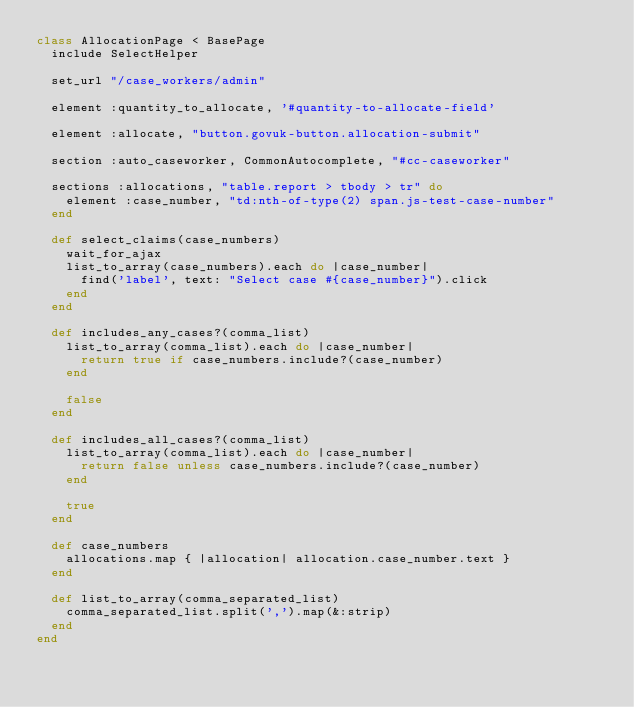<code> <loc_0><loc_0><loc_500><loc_500><_Ruby_>class AllocationPage < BasePage
  include SelectHelper

  set_url "/case_workers/admin"

  element :quantity_to_allocate, '#quantity-to-allocate-field'

  element :allocate, "button.govuk-button.allocation-submit"

  section :auto_caseworker, CommonAutocomplete, "#cc-caseworker"

  sections :allocations, "table.report > tbody > tr" do
    element :case_number, "td:nth-of-type(2) span.js-test-case-number"
  end

  def select_claims(case_numbers)
    wait_for_ajax
    list_to_array(case_numbers).each do |case_number|
      find('label', text: "Select case #{case_number}").click
    end
  end

  def includes_any_cases?(comma_list)
    list_to_array(comma_list).each do |case_number|
      return true if case_numbers.include?(case_number)
    end

    false
  end

  def includes_all_cases?(comma_list)
    list_to_array(comma_list).each do |case_number|
      return false unless case_numbers.include?(case_number)
    end

    true
  end

  def case_numbers
    allocations.map { |allocation| allocation.case_number.text }
  end

  def list_to_array(comma_separated_list)
    comma_separated_list.split(',').map(&:strip)
  end
end
</code> 